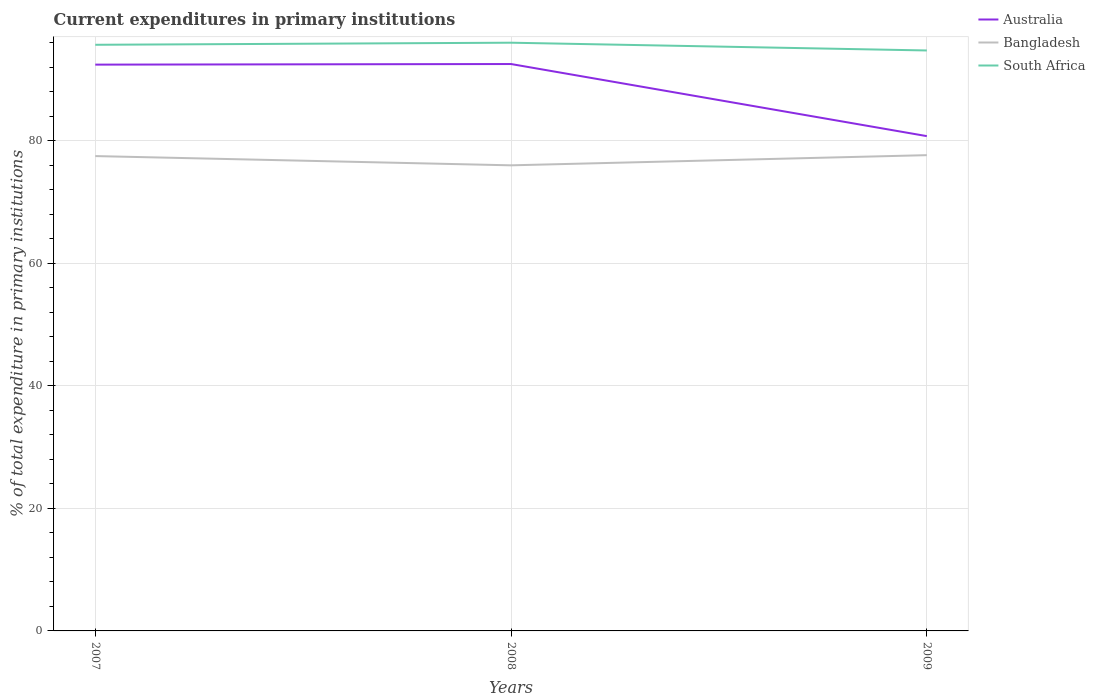How many different coloured lines are there?
Keep it short and to the point. 3. Across all years, what is the maximum current expenditures in primary institutions in South Africa?
Offer a terse response. 94.73. What is the total current expenditures in primary institutions in South Africa in the graph?
Keep it short and to the point. -0.34. What is the difference between the highest and the second highest current expenditures in primary institutions in Australia?
Make the answer very short. 11.77. What is the difference between the highest and the lowest current expenditures in primary institutions in South Africa?
Provide a succinct answer. 2. How many years are there in the graph?
Keep it short and to the point. 3. Are the values on the major ticks of Y-axis written in scientific E-notation?
Offer a terse response. No. Does the graph contain any zero values?
Provide a short and direct response. No. Does the graph contain grids?
Your response must be concise. Yes. Where does the legend appear in the graph?
Offer a very short reply. Top right. How many legend labels are there?
Ensure brevity in your answer.  3. How are the legend labels stacked?
Offer a terse response. Vertical. What is the title of the graph?
Give a very brief answer. Current expenditures in primary institutions. What is the label or title of the Y-axis?
Ensure brevity in your answer.  % of total expenditure in primary institutions. What is the % of total expenditure in primary institutions of Australia in 2007?
Your answer should be very brief. 92.42. What is the % of total expenditure in primary institutions of Bangladesh in 2007?
Your response must be concise. 77.5. What is the % of total expenditure in primary institutions of South Africa in 2007?
Your response must be concise. 95.66. What is the % of total expenditure in primary institutions in Australia in 2008?
Provide a short and direct response. 92.52. What is the % of total expenditure in primary institutions of Bangladesh in 2008?
Provide a succinct answer. 75.99. What is the % of total expenditure in primary institutions in South Africa in 2008?
Provide a short and direct response. 96. What is the % of total expenditure in primary institutions of Australia in 2009?
Your response must be concise. 80.75. What is the % of total expenditure in primary institutions of Bangladesh in 2009?
Provide a short and direct response. 77.65. What is the % of total expenditure in primary institutions of South Africa in 2009?
Keep it short and to the point. 94.73. Across all years, what is the maximum % of total expenditure in primary institutions in Australia?
Provide a short and direct response. 92.52. Across all years, what is the maximum % of total expenditure in primary institutions of Bangladesh?
Your response must be concise. 77.65. Across all years, what is the maximum % of total expenditure in primary institutions of South Africa?
Make the answer very short. 96. Across all years, what is the minimum % of total expenditure in primary institutions in Australia?
Keep it short and to the point. 80.75. Across all years, what is the minimum % of total expenditure in primary institutions in Bangladesh?
Ensure brevity in your answer.  75.99. Across all years, what is the minimum % of total expenditure in primary institutions in South Africa?
Offer a very short reply. 94.73. What is the total % of total expenditure in primary institutions in Australia in the graph?
Keep it short and to the point. 265.7. What is the total % of total expenditure in primary institutions of Bangladesh in the graph?
Give a very brief answer. 231.13. What is the total % of total expenditure in primary institutions in South Africa in the graph?
Ensure brevity in your answer.  286.4. What is the difference between the % of total expenditure in primary institutions of Australia in 2007 and that in 2008?
Ensure brevity in your answer.  -0.1. What is the difference between the % of total expenditure in primary institutions in Bangladesh in 2007 and that in 2008?
Provide a short and direct response. 1.51. What is the difference between the % of total expenditure in primary institutions of South Africa in 2007 and that in 2008?
Make the answer very short. -0.34. What is the difference between the % of total expenditure in primary institutions of Australia in 2007 and that in 2009?
Offer a terse response. 11.67. What is the difference between the % of total expenditure in primary institutions of Bangladesh in 2007 and that in 2009?
Your response must be concise. -0.15. What is the difference between the % of total expenditure in primary institutions in South Africa in 2007 and that in 2009?
Your answer should be very brief. 0.93. What is the difference between the % of total expenditure in primary institutions in Australia in 2008 and that in 2009?
Provide a short and direct response. 11.77. What is the difference between the % of total expenditure in primary institutions in Bangladesh in 2008 and that in 2009?
Your answer should be very brief. -1.66. What is the difference between the % of total expenditure in primary institutions of South Africa in 2008 and that in 2009?
Provide a succinct answer. 1.27. What is the difference between the % of total expenditure in primary institutions in Australia in 2007 and the % of total expenditure in primary institutions in Bangladesh in 2008?
Ensure brevity in your answer.  16.44. What is the difference between the % of total expenditure in primary institutions in Australia in 2007 and the % of total expenditure in primary institutions in South Africa in 2008?
Your answer should be compact. -3.58. What is the difference between the % of total expenditure in primary institutions in Bangladesh in 2007 and the % of total expenditure in primary institutions in South Africa in 2008?
Give a very brief answer. -18.5. What is the difference between the % of total expenditure in primary institutions of Australia in 2007 and the % of total expenditure in primary institutions of Bangladesh in 2009?
Your answer should be very brief. 14.78. What is the difference between the % of total expenditure in primary institutions in Australia in 2007 and the % of total expenditure in primary institutions in South Africa in 2009?
Give a very brief answer. -2.31. What is the difference between the % of total expenditure in primary institutions of Bangladesh in 2007 and the % of total expenditure in primary institutions of South Africa in 2009?
Make the answer very short. -17.24. What is the difference between the % of total expenditure in primary institutions in Australia in 2008 and the % of total expenditure in primary institutions in Bangladesh in 2009?
Offer a terse response. 14.87. What is the difference between the % of total expenditure in primary institutions in Australia in 2008 and the % of total expenditure in primary institutions in South Africa in 2009?
Your response must be concise. -2.21. What is the difference between the % of total expenditure in primary institutions of Bangladesh in 2008 and the % of total expenditure in primary institutions of South Africa in 2009?
Your answer should be very brief. -18.75. What is the average % of total expenditure in primary institutions of Australia per year?
Your answer should be compact. 88.57. What is the average % of total expenditure in primary institutions in Bangladesh per year?
Provide a short and direct response. 77.04. What is the average % of total expenditure in primary institutions of South Africa per year?
Provide a succinct answer. 95.47. In the year 2007, what is the difference between the % of total expenditure in primary institutions of Australia and % of total expenditure in primary institutions of Bangladesh?
Provide a short and direct response. 14.93. In the year 2007, what is the difference between the % of total expenditure in primary institutions of Australia and % of total expenditure in primary institutions of South Africa?
Provide a short and direct response. -3.24. In the year 2007, what is the difference between the % of total expenditure in primary institutions of Bangladesh and % of total expenditure in primary institutions of South Africa?
Provide a succinct answer. -18.17. In the year 2008, what is the difference between the % of total expenditure in primary institutions in Australia and % of total expenditure in primary institutions in Bangladesh?
Your answer should be compact. 16.53. In the year 2008, what is the difference between the % of total expenditure in primary institutions in Australia and % of total expenditure in primary institutions in South Africa?
Your answer should be compact. -3.48. In the year 2008, what is the difference between the % of total expenditure in primary institutions of Bangladesh and % of total expenditure in primary institutions of South Africa?
Make the answer very short. -20.01. In the year 2009, what is the difference between the % of total expenditure in primary institutions of Australia and % of total expenditure in primary institutions of Bangladesh?
Offer a very short reply. 3.11. In the year 2009, what is the difference between the % of total expenditure in primary institutions of Australia and % of total expenditure in primary institutions of South Africa?
Your answer should be very brief. -13.98. In the year 2009, what is the difference between the % of total expenditure in primary institutions of Bangladesh and % of total expenditure in primary institutions of South Africa?
Your answer should be compact. -17.09. What is the ratio of the % of total expenditure in primary institutions of Bangladesh in 2007 to that in 2008?
Your response must be concise. 1.02. What is the ratio of the % of total expenditure in primary institutions of South Africa in 2007 to that in 2008?
Your answer should be compact. 1. What is the ratio of the % of total expenditure in primary institutions in Australia in 2007 to that in 2009?
Offer a terse response. 1.14. What is the ratio of the % of total expenditure in primary institutions of Bangladesh in 2007 to that in 2009?
Your response must be concise. 1. What is the ratio of the % of total expenditure in primary institutions in South Africa in 2007 to that in 2009?
Make the answer very short. 1.01. What is the ratio of the % of total expenditure in primary institutions of Australia in 2008 to that in 2009?
Make the answer very short. 1.15. What is the ratio of the % of total expenditure in primary institutions in Bangladesh in 2008 to that in 2009?
Keep it short and to the point. 0.98. What is the ratio of the % of total expenditure in primary institutions of South Africa in 2008 to that in 2009?
Ensure brevity in your answer.  1.01. What is the difference between the highest and the second highest % of total expenditure in primary institutions in Australia?
Offer a terse response. 0.1. What is the difference between the highest and the second highest % of total expenditure in primary institutions in Bangladesh?
Offer a very short reply. 0.15. What is the difference between the highest and the second highest % of total expenditure in primary institutions in South Africa?
Provide a succinct answer. 0.34. What is the difference between the highest and the lowest % of total expenditure in primary institutions of Australia?
Ensure brevity in your answer.  11.77. What is the difference between the highest and the lowest % of total expenditure in primary institutions in Bangladesh?
Provide a succinct answer. 1.66. What is the difference between the highest and the lowest % of total expenditure in primary institutions of South Africa?
Provide a succinct answer. 1.27. 